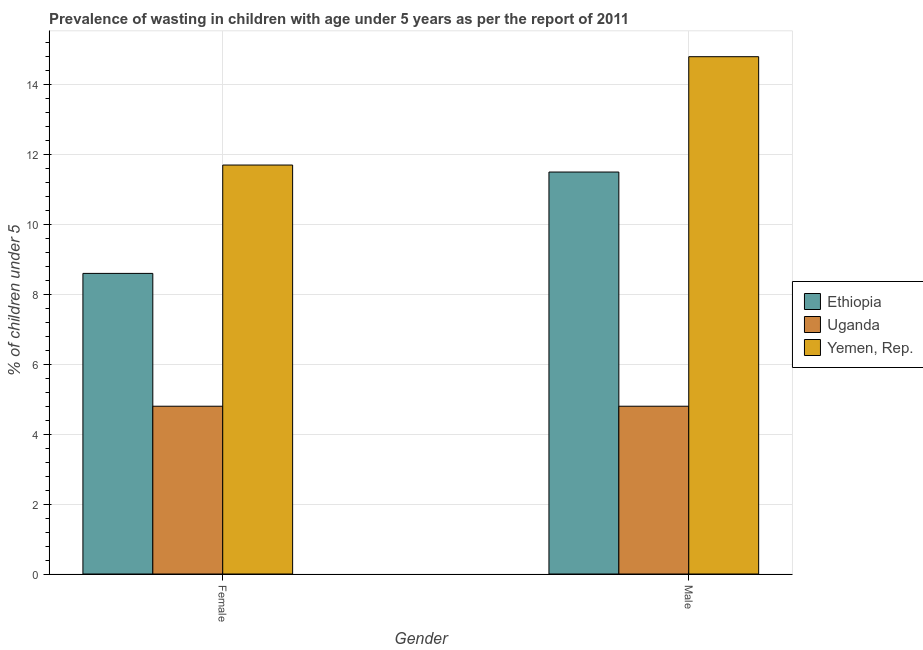How many different coloured bars are there?
Your answer should be compact. 3. Are the number of bars on each tick of the X-axis equal?
Make the answer very short. Yes. How many bars are there on the 1st tick from the left?
Make the answer very short. 3. How many bars are there on the 2nd tick from the right?
Your response must be concise. 3. What is the percentage of undernourished female children in Yemen, Rep.?
Your answer should be very brief. 11.7. Across all countries, what is the maximum percentage of undernourished female children?
Offer a terse response. 11.7. Across all countries, what is the minimum percentage of undernourished female children?
Keep it short and to the point. 4.8. In which country was the percentage of undernourished male children maximum?
Your response must be concise. Yemen, Rep. In which country was the percentage of undernourished female children minimum?
Your response must be concise. Uganda. What is the total percentage of undernourished female children in the graph?
Make the answer very short. 25.1. What is the difference between the percentage of undernourished female children in Yemen, Rep. and that in Ethiopia?
Provide a short and direct response. 3.1. What is the difference between the percentage of undernourished female children in Yemen, Rep. and the percentage of undernourished male children in Uganda?
Provide a succinct answer. 6.9. What is the average percentage of undernourished male children per country?
Ensure brevity in your answer.  10.37. What is the difference between the percentage of undernourished male children and percentage of undernourished female children in Yemen, Rep.?
Your response must be concise. 3.1. What is the ratio of the percentage of undernourished male children in Uganda to that in Ethiopia?
Keep it short and to the point. 0.42. What does the 2nd bar from the left in Female represents?
Your answer should be compact. Uganda. What does the 1st bar from the right in Male represents?
Ensure brevity in your answer.  Yemen, Rep. Are all the bars in the graph horizontal?
Keep it short and to the point. No. How many countries are there in the graph?
Make the answer very short. 3. What is the difference between two consecutive major ticks on the Y-axis?
Offer a terse response. 2. Are the values on the major ticks of Y-axis written in scientific E-notation?
Provide a short and direct response. No. Does the graph contain any zero values?
Keep it short and to the point. No. Where does the legend appear in the graph?
Offer a terse response. Center right. What is the title of the graph?
Ensure brevity in your answer.  Prevalence of wasting in children with age under 5 years as per the report of 2011. Does "Guatemala" appear as one of the legend labels in the graph?
Keep it short and to the point. No. What is the label or title of the Y-axis?
Your response must be concise.  % of children under 5. What is the  % of children under 5 of Ethiopia in Female?
Your response must be concise. 8.6. What is the  % of children under 5 of Uganda in Female?
Make the answer very short. 4.8. What is the  % of children under 5 in Yemen, Rep. in Female?
Your answer should be compact. 11.7. What is the  % of children under 5 of Ethiopia in Male?
Keep it short and to the point. 11.5. What is the  % of children under 5 of Uganda in Male?
Offer a terse response. 4.8. What is the  % of children under 5 in Yemen, Rep. in Male?
Give a very brief answer. 14.8. Across all Gender, what is the maximum  % of children under 5 of Uganda?
Give a very brief answer. 4.8. Across all Gender, what is the maximum  % of children under 5 in Yemen, Rep.?
Provide a succinct answer. 14.8. Across all Gender, what is the minimum  % of children under 5 of Ethiopia?
Keep it short and to the point. 8.6. Across all Gender, what is the minimum  % of children under 5 in Uganda?
Your answer should be very brief. 4.8. Across all Gender, what is the minimum  % of children under 5 in Yemen, Rep.?
Your answer should be compact. 11.7. What is the total  % of children under 5 in Ethiopia in the graph?
Your answer should be very brief. 20.1. What is the total  % of children under 5 in Uganda in the graph?
Provide a succinct answer. 9.6. What is the difference between the  % of children under 5 in Uganda in Female and the  % of children under 5 in Yemen, Rep. in Male?
Provide a short and direct response. -10. What is the average  % of children under 5 of Ethiopia per Gender?
Provide a short and direct response. 10.05. What is the average  % of children under 5 of Uganda per Gender?
Ensure brevity in your answer.  4.8. What is the average  % of children under 5 of Yemen, Rep. per Gender?
Your answer should be very brief. 13.25. What is the difference between the  % of children under 5 in Uganda and  % of children under 5 in Yemen, Rep. in Male?
Give a very brief answer. -10. What is the ratio of the  % of children under 5 in Ethiopia in Female to that in Male?
Make the answer very short. 0.75. What is the ratio of the  % of children under 5 of Yemen, Rep. in Female to that in Male?
Provide a short and direct response. 0.79. What is the difference between the highest and the second highest  % of children under 5 of Yemen, Rep.?
Your answer should be very brief. 3.1. What is the difference between the highest and the lowest  % of children under 5 in Uganda?
Keep it short and to the point. 0. 